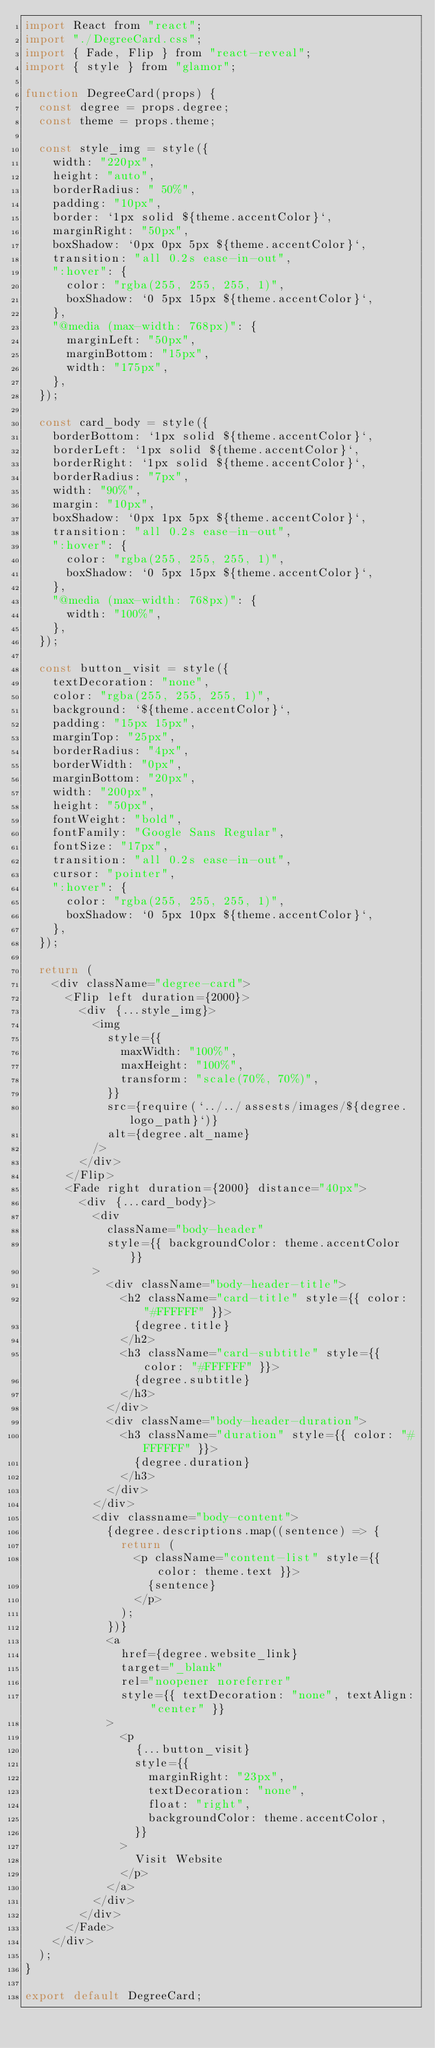Convert code to text. <code><loc_0><loc_0><loc_500><loc_500><_JavaScript_>import React from "react";
import "./DegreeCard.css";
import { Fade, Flip } from "react-reveal";
import { style } from "glamor";

function DegreeCard(props) {
  const degree = props.degree;
  const theme = props.theme;

  const style_img = style({
    width: "220px",
    height: "auto",
    borderRadius: " 50%",
    padding: "10px",
    border: `1px solid ${theme.accentColor}`,
    marginRight: "50px",
    boxShadow: `0px 0px 5px ${theme.accentColor}`,
    transition: "all 0.2s ease-in-out",
    ":hover": {
      color: "rgba(255, 255, 255, 1)",
      boxShadow: `0 5px 15px ${theme.accentColor}`,
    },
    "@media (max-width: 768px)": {
      marginLeft: "50px",
      marginBottom: "15px",
      width: "175px",
    },
  });

  const card_body = style({
    borderBottom: `1px solid ${theme.accentColor}`,
    borderLeft: `1px solid ${theme.accentColor}`,
    borderRight: `1px solid ${theme.accentColor}`,
    borderRadius: "7px",
    width: "90%",
    margin: "10px",
    boxShadow: `0px 1px 5px ${theme.accentColor}`,
    transition: "all 0.2s ease-in-out",
    ":hover": {
      color: "rgba(255, 255, 255, 1)",
      boxShadow: `0 5px 15px ${theme.accentColor}`,
    },
    "@media (max-width: 768px)": {
      width: "100%",
    },
  });

  const button_visit = style({
    textDecoration: "none",
    color: "rgba(255, 255, 255, 1)",
    background: `${theme.accentColor}`,
    padding: "15px 15px",
    marginTop: "25px",
    borderRadius: "4px",
    borderWidth: "0px",
    marginBottom: "20px",
    width: "200px",
    height: "50px",
    fontWeight: "bold",
    fontFamily: "Google Sans Regular",
    fontSize: "17px",
    transition: "all 0.2s ease-in-out",
    cursor: "pointer",
    ":hover": {
      color: "rgba(255, 255, 255, 1)",
      boxShadow: `0 5px 10px ${theme.accentColor}`,
    },
  });

  return (
    <div className="degree-card">
      <Flip left duration={2000}>
        <div {...style_img}>
          <img
            style={{
              maxWidth: "100%",
              maxHeight: "100%",
              transform: "scale(70%, 70%)",
            }}
            src={require(`../../assests/images/${degree.logo_path}`)}
            alt={degree.alt_name}
          />
        </div>
      </Flip>
      <Fade right duration={2000} distance="40px">
        <div {...card_body}>
          <div
            className="body-header"
            style={{ backgroundColor: theme.accentColor }}
          >
            <div className="body-header-title">
              <h2 className="card-title" style={{ color: "#FFFFFF" }}>
                {degree.title}
              </h2>
              <h3 className="card-subtitle" style={{ color: "#FFFFFF" }}>
                {degree.subtitle}
              </h3>
            </div>
            <div className="body-header-duration">
              <h3 className="duration" style={{ color: "#FFFFFF" }}>
                {degree.duration}
              </h3>
            </div>
          </div>
          <div classname="body-content">
            {degree.descriptions.map((sentence) => {
              return (
                <p className="content-list" style={{ color: theme.text }}>
                  {sentence}
                </p>
              );
            })}
            <a
              href={degree.website_link}
              target="_blank"
              rel="noopener noreferrer"
              style={{ textDecoration: "none", textAlign: "center" }}
            >
              <p
                {...button_visit}
                style={{
                  marginRight: "23px",
                  textDecoration: "none",
                  float: "right",
                  backgroundColor: theme.accentColor,
                }}
              >
                Visit Website
              </p>
            </a>
          </div>
        </div>
      </Fade>
    </div>
  );
}

export default DegreeCard;
</code> 